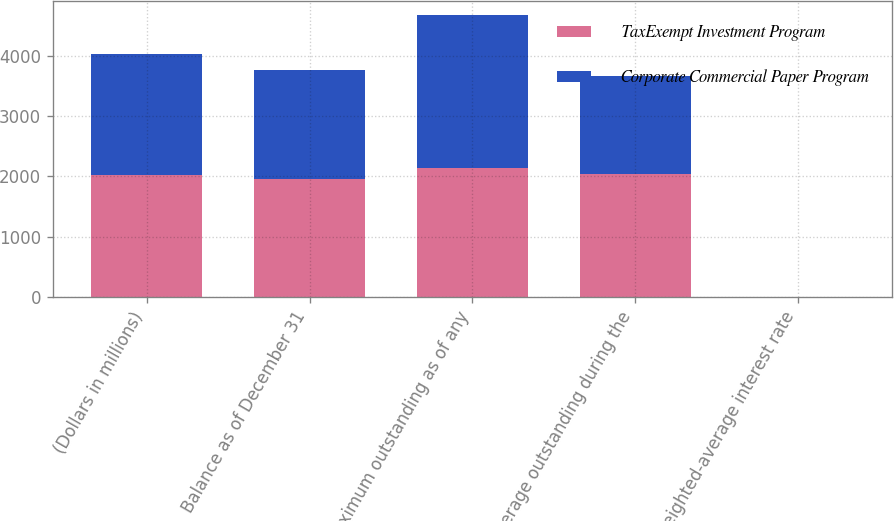Convert chart to OTSL. <chart><loc_0><loc_0><loc_500><loc_500><stacked_bar_chart><ecel><fcel>(Dollars in millions)<fcel>Balance as of December 31<fcel>Maximum outstanding as of any<fcel>Average outstanding during the<fcel>Weighted-average interest rate<nl><fcel>TaxExempt Investment Program<fcel>2013<fcel>1948<fcel>2135<fcel>2030<fcel>0.13<nl><fcel>Corporate Commercial Paper Program<fcel>2013<fcel>1819<fcel>2535<fcel>1632<fcel>0.18<nl></chart> 